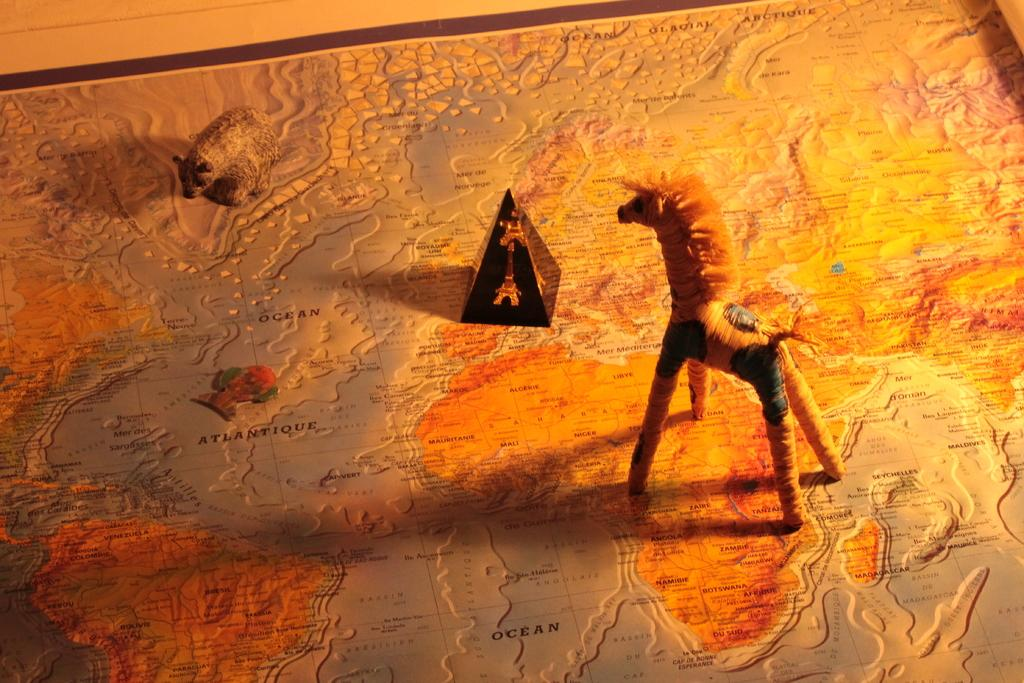How many toys are present in the image? There are two toys in the image. Can you describe the object on the map in the image? Unfortunately, the facts provided do not give any details about the object on the map. What type of need can be seen near the toys in the image? There is no mention of a need in the image, as the facts only mention two toys and an object on a map. 